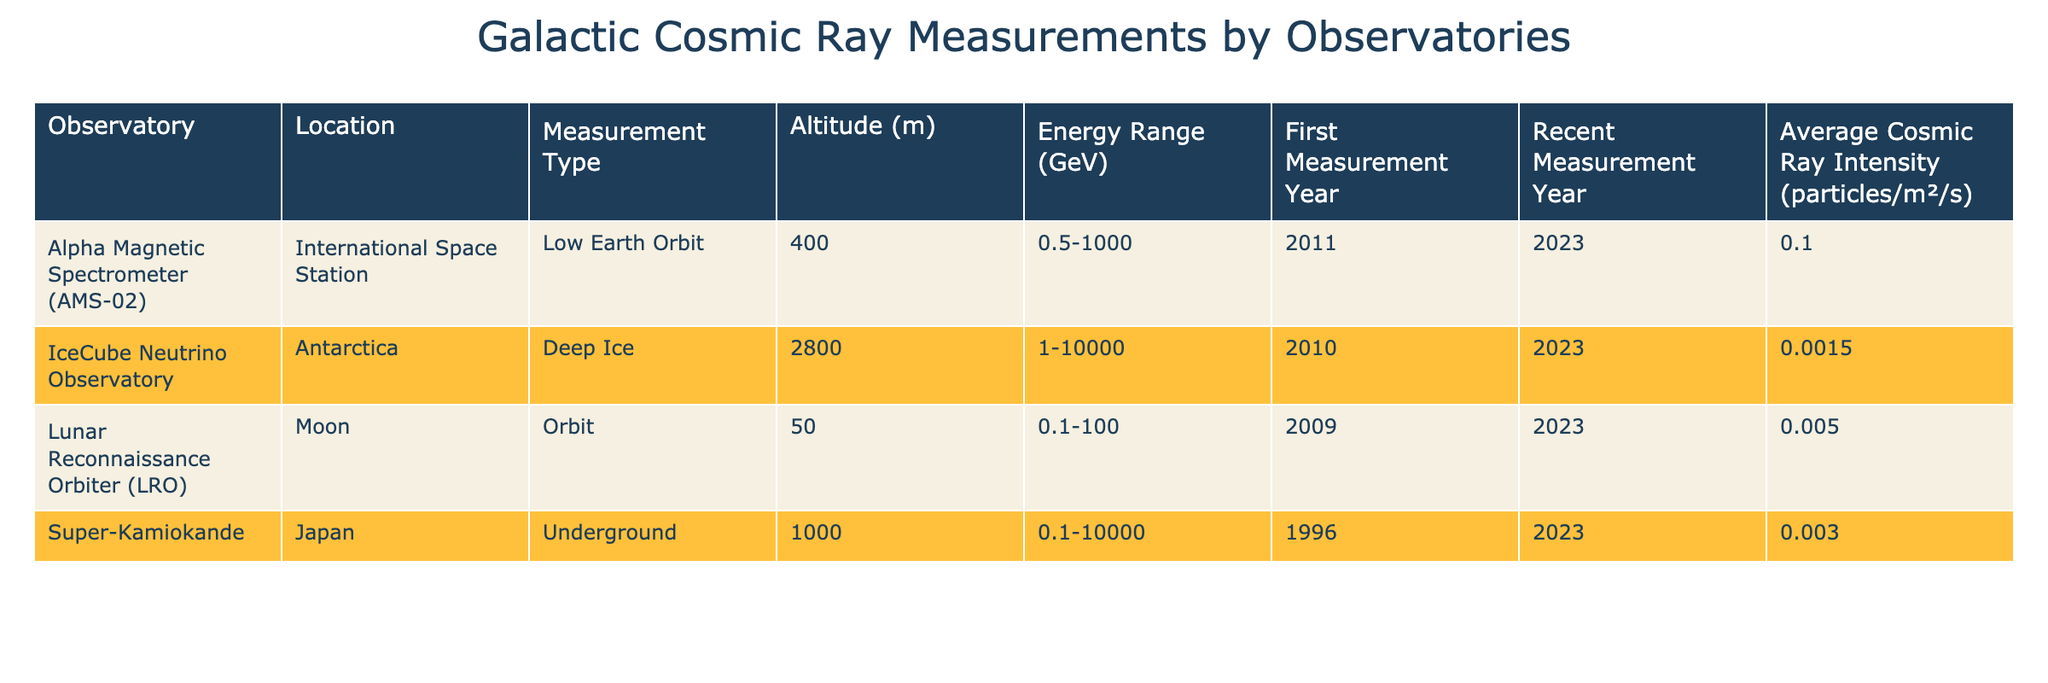What is the average cosmic ray intensity measured by the Lunar Reconnaissance Orbiter? The table shows that the average cosmic ray intensity for the Lunar Reconnaissance Orbiter is listed as 0.005 particles/m²/s.
Answer: 0.005 Which observatory has the highest altitude of measurement? Among the observatories listed, the IceCube Neutrino Observatory has the highest altitude of measurement at 2800 meters.
Answer: IceCube Neutrino Observatory How many observatories have an energy range of 1 GeV or higher? By reviewing the table, the Alpha Magnetic Spectrometer, IceCube Neutrino Observatory, and Super-Kamiokande have energy ranges starting at 0.5 GeV, 1 GeV, and 0.1 GeV respectively. Hence, all four observatories have energy ranges equal to or greater than 1 GeV.
Answer: All four observatories What is the difference in cosmic ray intensity between the IceCube Neutrino Observatory and Super-Kamiokande? IceCube Neutrino Observatory has an average cosmic ray intensity of 0.0015 particles/m²/s, while Super-Kamiokande has 0.003 particles/m²/s. The difference is calculated as 0.003 - 0.0015 = 0.0015 particles/m²/s.
Answer: 0.0015 Is the first measurement year for the Alpha Magnetic Spectrometer later than the Lunar Reconnaissance Orbiter? The first measurement year for the Alpha Magnetic Spectrometer is 2011, whereas for the Lunar Reconnaissance Orbiter, it is 2009. Thus, 2011 is later than 2009.
Answer: Yes What is the range of cosmic ray intensities for the observatories listed in the table? The average cosmic ray intensities are: 0.1 (AMS-02), 0.0015 (IceCube), 0.005 (LRO), and 0.003 (Super-Kamiokande). The highest is 0.1 from AMS-02, and the lowest is 0.0015 from IceCube. Hence, the range is 0.1 - 0.0015 = 0.0985 particles/m²/s.
Answer: 0.0985 Which observatory is located in the deepest location, and how does it compare with the other locations? The IceCube Neutrino Observatory is located in Antarctica at an altitude of 2800 meters, making it the deepest compared to others. The AMS-02 is in Low Earth Orbit (400 m), LRO is at 50 m, and Super-Kamiokande is subterranean at 1000 m; thus, IceCube is the deepest.
Answer: IceCube Neutrino Observatory What is the average energy range across all observatories listed? The energy ranges are: AMS-02: 0.5-1000, IceCube: 1-10000, LRO: 0.1-100, and Super-Kamiokande: 0.1-10000. To find an average range, we can consider the minimum and maximum ranges. The lowest minimum is 0.1 and the highest maximum is 10000, leading to an average range conceptually between these values. However, numerical averages are generally complex without additional processing. Hence, an average energy range cannot easily be determined from this data.
Answer: Indeterminate 